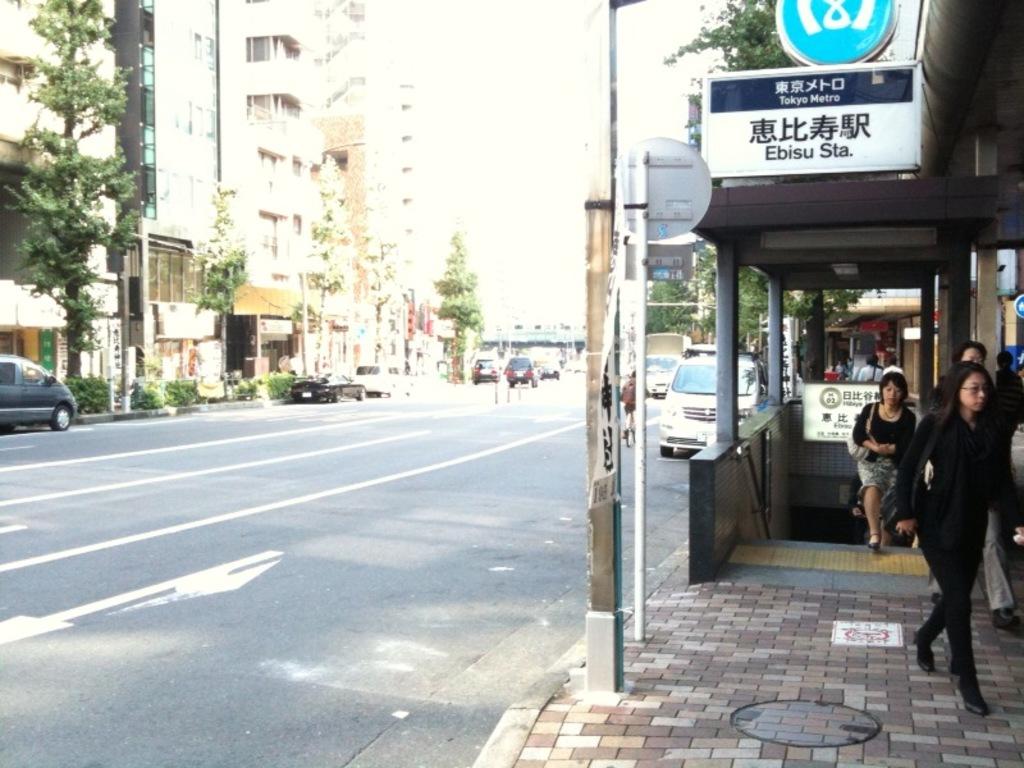What is the name of the station?
Offer a terse response. Unanswerable. Where are they going to?
Your answer should be very brief. Unanswerable. 